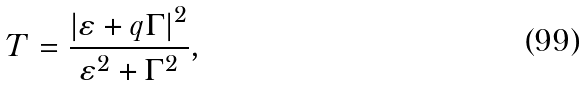<formula> <loc_0><loc_0><loc_500><loc_500>T = { \frac { { { \left | { \varepsilon + q \Gamma } \right | } ^ { 2 } } } { { \varepsilon ^ { 2 } + \Gamma ^ { 2 } } } } ,</formula> 